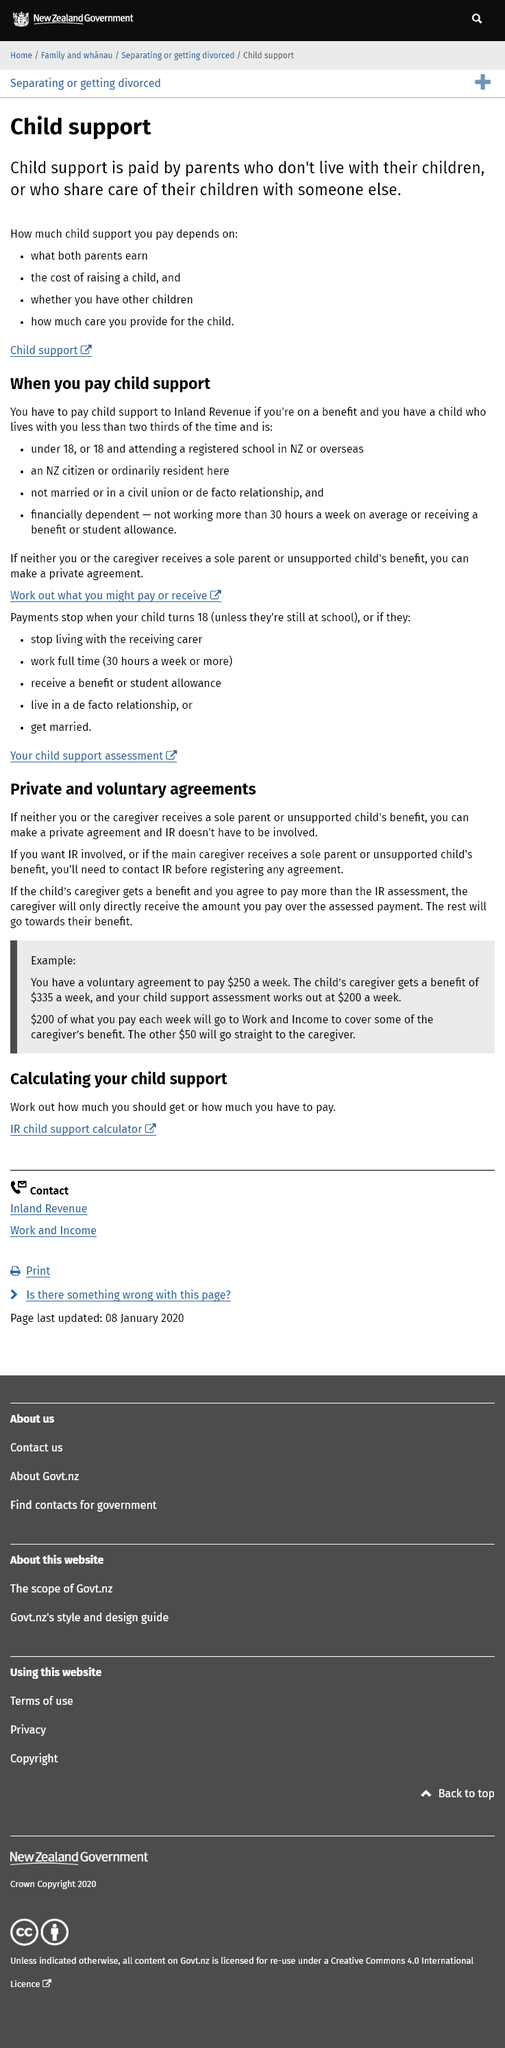Specify some key components in this picture. Child support is not a fixed amount per child, but rather it depends on various factors such as the income of both parents, the cost of raising a child, the number of children, and the amount of care provided for the child. If you have a child born outside of New Zealand and you are responsible for their care, you may be required to pay child support. This support is typically paid for children who live with you for less than two thirds of the time and are either a New Zealand citizen or ordinarily resident in New Zealand. Parents who share care of their children with someone else or who do not live with their children are required to pay child support in certain circumstances. 